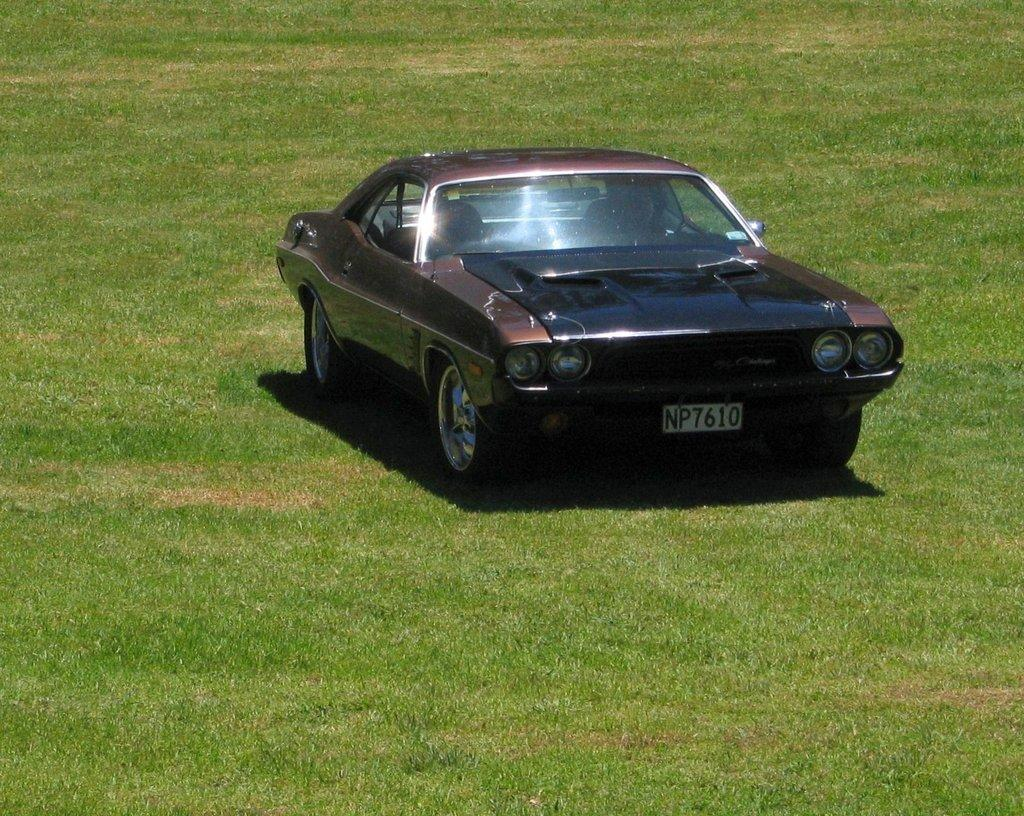What is the main subject in the center of the image? There is a car in the center of the image. What type of terrain is visible at the bottom of the image? There is grass at the bottom of the image. How many friends can be seen in the image? There are no friends visible in the image; it only features a car and grass. What color is the eye of the car in the image? Cars do not have eyes, so this question cannot be answered based on the image. 